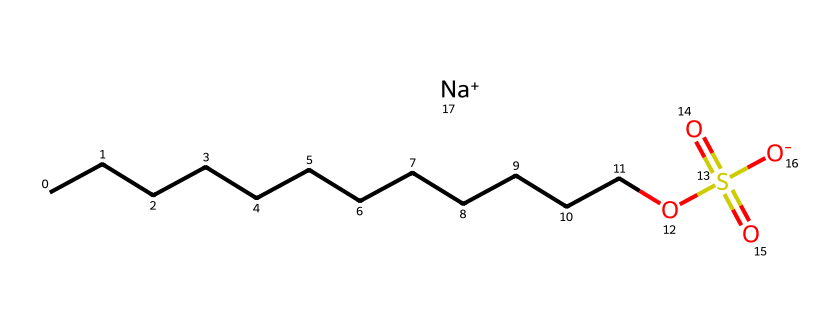How many carbon atoms are in sodium lauryl sulfate? By analyzing the structure, the long hydrocarbon chain represented by CCCCCCCCCCCC indicates there are 12 carbon atoms in total.
Answer: twelve What functional group is present in sodium lauryl sulfate? The presence of the -OS(=O)(=O)[O-] part of the structure indicates it contains a sulfonate (sulfonic acid) functional group.
Answer: sulfonate What is the molecular formula of sodium lauryl sulfate? To determine the molecular formula, count the atoms represented in the SMILES: 12 carbons (C), 26 hydrogens (H), 1 oxygen (O) from the sulfonate, and sodium (Na), leading to the formula C12H25NaO4S.
Answer: C12H25NaO4S Is sodium lauryl sulfate an anionic or cationic surfactant? The presence of the sodium ion (Na+) and the negatively charged sulfonate group indicates that sodium lauryl sulfate is an anionic surfactant.
Answer: anionic How many total oxygen atoms are present in sodium lauryl sulfate? Looking at the structure, there is one oxygen in the -OS(=O)(=O) part and three from the sulfonate group, giving a total of four oxygen atoms.
Answer: four What role does sodium lauryl sulfate play in furniture polish? Sodium lauryl sulfate acts as a surfactant, which helps to lower the surface tension, aiding in the removal of dirt and grease from surfaces.
Answer: surfactant 